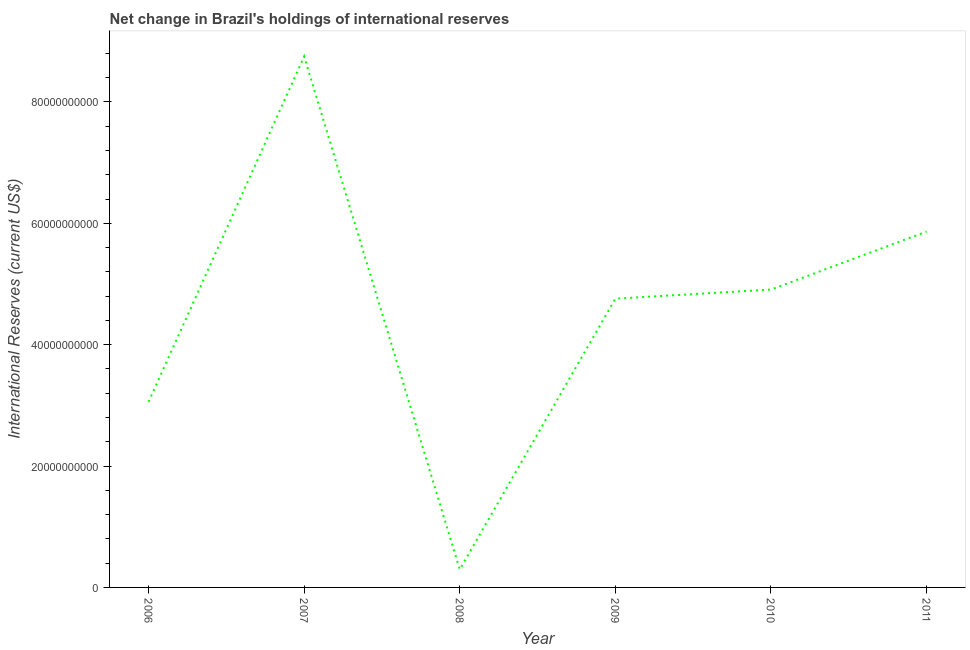What is the reserves and related items in 2011?
Provide a succinct answer. 5.86e+1. Across all years, what is the maximum reserves and related items?
Keep it short and to the point. 8.75e+1. Across all years, what is the minimum reserves and related items?
Give a very brief answer. 2.97e+09. In which year was the reserves and related items maximum?
Give a very brief answer. 2007. In which year was the reserves and related items minimum?
Make the answer very short. 2008. What is the sum of the reserves and related items?
Offer a very short reply. 2.76e+11. What is the difference between the reserves and related items in 2007 and 2009?
Your response must be concise. 3.99e+1. What is the average reserves and related items per year?
Provide a short and direct response. 4.61e+1. What is the median reserves and related items?
Make the answer very short. 4.83e+1. In how many years, is the reserves and related items greater than 80000000000 US$?
Your answer should be very brief. 1. Do a majority of the years between 2010 and 2006 (inclusive) have reserves and related items greater than 28000000000 US$?
Keep it short and to the point. Yes. What is the ratio of the reserves and related items in 2007 to that in 2009?
Ensure brevity in your answer.  1.84. Is the reserves and related items in 2006 less than that in 2008?
Ensure brevity in your answer.  No. What is the difference between the highest and the second highest reserves and related items?
Keep it short and to the point. 2.88e+1. Is the sum of the reserves and related items in 2007 and 2011 greater than the maximum reserves and related items across all years?
Provide a short and direct response. Yes. What is the difference between the highest and the lowest reserves and related items?
Your answer should be very brief. 8.45e+1. In how many years, is the reserves and related items greater than the average reserves and related items taken over all years?
Provide a short and direct response. 4. What is the title of the graph?
Make the answer very short. Net change in Brazil's holdings of international reserves. What is the label or title of the Y-axis?
Your response must be concise. International Reserves (current US$). What is the International Reserves (current US$) of 2006?
Your response must be concise. 3.06e+1. What is the International Reserves (current US$) in 2007?
Your answer should be compact. 8.75e+1. What is the International Reserves (current US$) in 2008?
Your answer should be compact. 2.97e+09. What is the International Reserves (current US$) in 2009?
Your answer should be compact. 4.76e+1. What is the International Reserves (current US$) of 2010?
Offer a very short reply. 4.91e+1. What is the International Reserves (current US$) of 2011?
Provide a succinct answer. 5.86e+1. What is the difference between the International Reserves (current US$) in 2006 and 2007?
Offer a terse response. -5.69e+1. What is the difference between the International Reserves (current US$) in 2006 and 2008?
Keep it short and to the point. 2.76e+1. What is the difference between the International Reserves (current US$) in 2006 and 2009?
Make the answer very short. -1.70e+1. What is the difference between the International Reserves (current US$) in 2006 and 2010?
Your answer should be compact. -1.85e+1. What is the difference between the International Reserves (current US$) in 2006 and 2011?
Your answer should be compact. -2.81e+1. What is the difference between the International Reserves (current US$) in 2007 and 2008?
Provide a succinct answer. 8.45e+1. What is the difference between the International Reserves (current US$) in 2007 and 2009?
Offer a terse response. 3.99e+1. What is the difference between the International Reserves (current US$) in 2007 and 2010?
Provide a succinct answer. 3.84e+1. What is the difference between the International Reserves (current US$) in 2007 and 2011?
Your response must be concise. 2.88e+1. What is the difference between the International Reserves (current US$) in 2008 and 2009?
Ensure brevity in your answer.  -4.46e+1. What is the difference between the International Reserves (current US$) in 2008 and 2010?
Give a very brief answer. -4.61e+1. What is the difference between the International Reserves (current US$) in 2008 and 2011?
Make the answer very short. -5.57e+1. What is the difference between the International Reserves (current US$) in 2009 and 2010?
Give a very brief answer. -1.50e+09. What is the difference between the International Reserves (current US$) in 2009 and 2011?
Provide a short and direct response. -1.11e+1. What is the difference between the International Reserves (current US$) in 2010 and 2011?
Ensure brevity in your answer.  -9.55e+09. What is the ratio of the International Reserves (current US$) in 2006 to that in 2007?
Offer a terse response. 0.35. What is the ratio of the International Reserves (current US$) in 2006 to that in 2008?
Offer a terse response. 10.29. What is the ratio of the International Reserves (current US$) in 2006 to that in 2009?
Your response must be concise. 0.64. What is the ratio of the International Reserves (current US$) in 2006 to that in 2010?
Offer a terse response. 0.62. What is the ratio of the International Reserves (current US$) in 2006 to that in 2011?
Provide a succinct answer. 0.52. What is the ratio of the International Reserves (current US$) in 2007 to that in 2008?
Provide a short and direct response. 29.46. What is the ratio of the International Reserves (current US$) in 2007 to that in 2009?
Ensure brevity in your answer.  1.84. What is the ratio of the International Reserves (current US$) in 2007 to that in 2010?
Give a very brief answer. 1.78. What is the ratio of the International Reserves (current US$) in 2007 to that in 2011?
Keep it short and to the point. 1.49. What is the ratio of the International Reserves (current US$) in 2008 to that in 2009?
Your response must be concise. 0.06. What is the ratio of the International Reserves (current US$) in 2008 to that in 2011?
Your response must be concise. 0.05. What is the ratio of the International Reserves (current US$) in 2009 to that in 2010?
Keep it short and to the point. 0.97. What is the ratio of the International Reserves (current US$) in 2009 to that in 2011?
Your answer should be very brief. 0.81. What is the ratio of the International Reserves (current US$) in 2010 to that in 2011?
Your response must be concise. 0.84. 